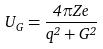<formula> <loc_0><loc_0><loc_500><loc_500>U _ { G } = \frac { 4 \pi Z e } { q ^ { 2 } + G ^ { 2 } }</formula> 